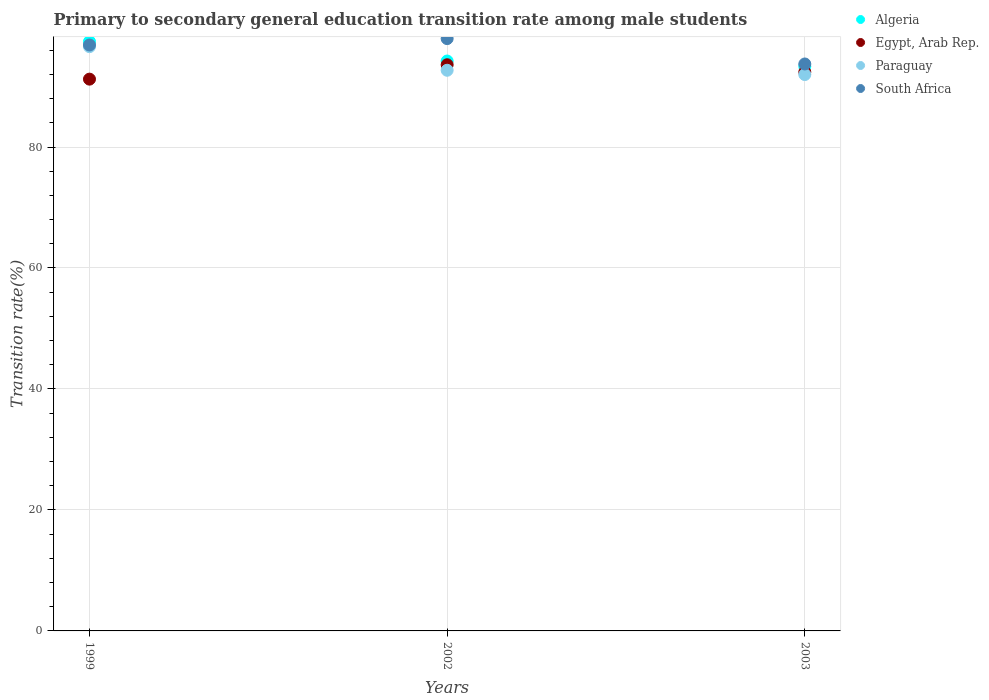What is the transition rate in Algeria in 2002?
Provide a succinct answer. 94.22. Across all years, what is the maximum transition rate in South Africa?
Provide a short and direct response. 97.92. Across all years, what is the minimum transition rate in Egypt, Arab Rep.?
Provide a short and direct response. 91.22. What is the total transition rate in Paraguay in the graph?
Keep it short and to the point. 281.25. What is the difference between the transition rate in South Africa in 1999 and that in 2002?
Keep it short and to the point. -1.06. What is the difference between the transition rate in South Africa in 2002 and the transition rate in Egypt, Arab Rep. in 2003?
Make the answer very short. 5.53. What is the average transition rate in Egypt, Arab Rep. per year?
Offer a terse response. 92.4. In the year 1999, what is the difference between the transition rate in Algeria and transition rate in Paraguay?
Give a very brief answer. 0.84. What is the ratio of the transition rate in Algeria in 1999 to that in 2003?
Your answer should be compact. 1.04. What is the difference between the highest and the second highest transition rate in Algeria?
Your answer should be very brief. 3.21. What is the difference between the highest and the lowest transition rate in Egypt, Arab Rep.?
Your answer should be very brief. 2.38. Is the sum of the transition rate in Algeria in 1999 and 2002 greater than the maximum transition rate in Egypt, Arab Rep. across all years?
Offer a terse response. Yes. Is it the case that in every year, the sum of the transition rate in South Africa and transition rate in Egypt, Arab Rep.  is greater than the transition rate in Algeria?
Your answer should be compact. Yes. Does the transition rate in Algeria monotonically increase over the years?
Ensure brevity in your answer.  No. Is the transition rate in South Africa strictly greater than the transition rate in Algeria over the years?
Provide a short and direct response. No. What is the difference between two consecutive major ticks on the Y-axis?
Offer a terse response. 20. Are the values on the major ticks of Y-axis written in scientific E-notation?
Your response must be concise. No. Does the graph contain any zero values?
Provide a succinct answer. No. How many legend labels are there?
Your response must be concise. 4. How are the legend labels stacked?
Offer a terse response. Vertical. What is the title of the graph?
Your response must be concise. Primary to secondary general education transition rate among male students. Does "Latin America(all income levels)" appear as one of the legend labels in the graph?
Make the answer very short. No. What is the label or title of the Y-axis?
Keep it short and to the point. Transition rate(%). What is the Transition rate(%) in Algeria in 1999?
Your answer should be compact. 97.42. What is the Transition rate(%) of Egypt, Arab Rep. in 1999?
Offer a terse response. 91.22. What is the Transition rate(%) of Paraguay in 1999?
Offer a terse response. 96.59. What is the Transition rate(%) of South Africa in 1999?
Ensure brevity in your answer.  96.86. What is the Transition rate(%) of Algeria in 2002?
Make the answer very short. 94.22. What is the Transition rate(%) in Egypt, Arab Rep. in 2002?
Offer a very short reply. 93.6. What is the Transition rate(%) of Paraguay in 2002?
Keep it short and to the point. 92.69. What is the Transition rate(%) of South Africa in 2002?
Offer a terse response. 97.92. What is the Transition rate(%) in Algeria in 2003?
Ensure brevity in your answer.  93.33. What is the Transition rate(%) in Egypt, Arab Rep. in 2003?
Provide a short and direct response. 92.39. What is the Transition rate(%) in Paraguay in 2003?
Offer a very short reply. 91.98. What is the Transition rate(%) of South Africa in 2003?
Your response must be concise. 93.73. Across all years, what is the maximum Transition rate(%) in Algeria?
Make the answer very short. 97.42. Across all years, what is the maximum Transition rate(%) in Egypt, Arab Rep.?
Offer a very short reply. 93.6. Across all years, what is the maximum Transition rate(%) in Paraguay?
Keep it short and to the point. 96.59. Across all years, what is the maximum Transition rate(%) in South Africa?
Make the answer very short. 97.92. Across all years, what is the minimum Transition rate(%) in Algeria?
Make the answer very short. 93.33. Across all years, what is the minimum Transition rate(%) of Egypt, Arab Rep.?
Your response must be concise. 91.22. Across all years, what is the minimum Transition rate(%) of Paraguay?
Give a very brief answer. 91.98. Across all years, what is the minimum Transition rate(%) in South Africa?
Ensure brevity in your answer.  93.73. What is the total Transition rate(%) in Algeria in the graph?
Keep it short and to the point. 284.97. What is the total Transition rate(%) of Egypt, Arab Rep. in the graph?
Make the answer very short. 277.21. What is the total Transition rate(%) in Paraguay in the graph?
Your answer should be compact. 281.25. What is the total Transition rate(%) of South Africa in the graph?
Ensure brevity in your answer.  288.51. What is the difference between the Transition rate(%) in Algeria in 1999 and that in 2002?
Give a very brief answer. 3.21. What is the difference between the Transition rate(%) in Egypt, Arab Rep. in 1999 and that in 2002?
Give a very brief answer. -2.38. What is the difference between the Transition rate(%) in Paraguay in 1999 and that in 2002?
Keep it short and to the point. 3.9. What is the difference between the Transition rate(%) of South Africa in 1999 and that in 2002?
Make the answer very short. -1.06. What is the difference between the Transition rate(%) of Algeria in 1999 and that in 2003?
Make the answer very short. 4.1. What is the difference between the Transition rate(%) of Egypt, Arab Rep. in 1999 and that in 2003?
Your answer should be compact. -1.17. What is the difference between the Transition rate(%) in Paraguay in 1999 and that in 2003?
Give a very brief answer. 4.61. What is the difference between the Transition rate(%) of South Africa in 1999 and that in 2003?
Keep it short and to the point. 3.14. What is the difference between the Transition rate(%) of Algeria in 2002 and that in 2003?
Ensure brevity in your answer.  0.89. What is the difference between the Transition rate(%) of Egypt, Arab Rep. in 2002 and that in 2003?
Offer a very short reply. 1.21. What is the difference between the Transition rate(%) of Paraguay in 2002 and that in 2003?
Keep it short and to the point. 0.71. What is the difference between the Transition rate(%) in South Africa in 2002 and that in 2003?
Make the answer very short. 4.19. What is the difference between the Transition rate(%) in Algeria in 1999 and the Transition rate(%) in Egypt, Arab Rep. in 2002?
Your answer should be compact. 3.83. What is the difference between the Transition rate(%) of Algeria in 1999 and the Transition rate(%) of Paraguay in 2002?
Keep it short and to the point. 4.74. What is the difference between the Transition rate(%) of Algeria in 1999 and the Transition rate(%) of South Africa in 2002?
Offer a very short reply. -0.5. What is the difference between the Transition rate(%) of Egypt, Arab Rep. in 1999 and the Transition rate(%) of Paraguay in 2002?
Provide a succinct answer. -1.47. What is the difference between the Transition rate(%) in Egypt, Arab Rep. in 1999 and the Transition rate(%) in South Africa in 2002?
Make the answer very short. -6.7. What is the difference between the Transition rate(%) in Paraguay in 1999 and the Transition rate(%) in South Africa in 2002?
Offer a terse response. -1.33. What is the difference between the Transition rate(%) in Algeria in 1999 and the Transition rate(%) in Egypt, Arab Rep. in 2003?
Provide a short and direct response. 5.03. What is the difference between the Transition rate(%) of Algeria in 1999 and the Transition rate(%) of Paraguay in 2003?
Make the answer very short. 5.45. What is the difference between the Transition rate(%) in Algeria in 1999 and the Transition rate(%) in South Africa in 2003?
Your answer should be very brief. 3.7. What is the difference between the Transition rate(%) in Egypt, Arab Rep. in 1999 and the Transition rate(%) in Paraguay in 2003?
Give a very brief answer. -0.76. What is the difference between the Transition rate(%) in Egypt, Arab Rep. in 1999 and the Transition rate(%) in South Africa in 2003?
Your answer should be compact. -2.51. What is the difference between the Transition rate(%) in Paraguay in 1999 and the Transition rate(%) in South Africa in 2003?
Ensure brevity in your answer.  2.86. What is the difference between the Transition rate(%) of Algeria in 2002 and the Transition rate(%) of Egypt, Arab Rep. in 2003?
Give a very brief answer. 1.82. What is the difference between the Transition rate(%) in Algeria in 2002 and the Transition rate(%) in Paraguay in 2003?
Your response must be concise. 2.24. What is the difference between the Transition rate(%) in Algeria in 2002 and the Transition rate(%) in South Africa in 2003?
Ensure brevity in your answer.  0.49. What is the difference between the Transition rate(%) in Egypt, Arab Rep. in 2002 and the Transition rate(%) in Paraguay in 2003?
Make the answer very short. 1.62. What is the difference between the Transition rate(%) of Egypt, Arab Rep. in 2002 and the Transition rate(%) of South Africa in 2003?
Your answer should be very brief. -0.13. What is the difference between the Transition rate(%) of Paraguay in 2002 and the Transition rate(%) of South Africa in 2003?
Offer a very short reply. -1.04. What is the average Transition rate(%) in Algeria per year?
Provide a short and direct response. 94.99. What is the average Transition rate(%) of Egypt, Arab Rep. per year?
Give a very brief answer. 92.4. What is the average Transition rate(%) of Paraguay per year?
Offer a very short reply. 93.75. What is the average Transition rate(%) in South Africa per year?
Ensure brevity in your answer.  96.17. In the year 1999, what is the difference between the Transition rate(%) in Algeria and Transition rate(%) in Egypt, Arab Rep.?
Provide a succinct answer. 6.2. In the year 1999, what is the difference between the Transition rate(%) in Algeria and Transition rate(%) in Paraguay?
Provide a succinct answer. 0.84. In the year 1999, what is the difference between the Transition rate(%) of Algeria and Transition rate(%) of South Africa?
Make the answer very short. 0.56. In the year 1999, what is the difference between the Transition rate(%) of Egypt, Arab Rep. and Transition rate(%) of Paraguay?
Provide a succinct answer. -5.37. In the year 1999, what is the difference between the Transition rate(%) of Egypt, Arab Rep. and Transition rate(%) of South Africa?
Your answer should be very brief. -5.64. In the year 1999, what is the difference between the Transition rate(%) of Paraguay and Transition rate(%) of South Africa?
Your answer should be compact. -0.28. In the year 2002, what is the difference between the Transition rate(%) of Algeria and Transition rate(%) of Egypt, Arab Rep.?
Your answer should be very brief. 0.62. In the year 2002, what is the difference between the Transition rate(%) in Algeria and Transition rate(%) in Paraguay?
Provide a short and direct response. 1.53. In the year 2002, what is the difference between the Transition rate(%) in Algeria and Transition rate(%) in South Africa?
Make the answer very short. -3.71. In the year 2002, what is the difference between the Transition rate(%) of Egypt, Arab Rep. and Transition rate(%) of Paraguay?
Offer a very short reply. 0.91. In the year 2002, what is the difference between the Transition rate(%) in Egypt, Arab Rep. and Transition rate(%) in South Africa?
Ensure brevity in your answer.  -4.32. In the year 2002, what is the difference between the Transition rate(%) in Paraguay and Transition rate(%) in South Africa?
Make the answer very short. -5.23. In the year 2003, what is the difference between the Transition rate(%) of Algeria and Transition rate(%) of Egypt, Arab Rep.?
Provide a succinct answer. 0.93. In the year 2003, what is the difference between the Transition rate(%) in Algeria and Transition rate(%) in Paraguay?
Offer a terse response. 1.35. In the year 2003, what is the difference between the Transition rate(%) of Algeria and Transition rate(%) of South Africa?
Give a very brief answer. -0.4. In the year 2003, what is the difference between the Transition rate(%) in Egypt, Arab Rep. and Transition rate(%) in Paraguay?
Make the answer very short. 0.41. In the year 2003, what is the difference between the Transition rate(%) of Egypt, Arab Rep. and Transition rate(%) of South Africa?
Make the answer very short. -1.33. In the year 2003, what is the difference between the Transition rate(%) of Paraguay and Transition rate(%) of South Africa?
Ensure brevity in your answer.  -1.75. What is the ratio of the Transition rate(%) in Algeria in 1999 to that in 2002?
Provide a succinct answer. 1.03. What is the ratio of the Transition rate(%) in Egypt, Arab Rep. in 1999 to that in 2002?
Keep it short and to the point. 0.97. What is the ratio of the Transition rate(%) in Paraguay in 1999 to that in 2002?
Your answer should be compact. 1.04. What is the ratio of the Transition rate(%) in South Africa in 1999 to that in 2002?
Make the answer very short. 0.99. What is the ratio of the Transition rate(%) of Algeria in 1999 to that in 2003?
Provide a succinct answer. 1.04. What is the ratio of the Transition rate(%) of Egypt, Arab Rep. in 1999 to that in 2003?
Offer a very short reply. 0.99. What is the ratio of the Transition rate(%) of Paraguay in 1999 to that in 2003?
Your response must be concise. 1.05. What is the ratio of the Transition rate(%) of South Africa in 1999 to that in 2003?
Keep it short and to the point. 1.03. What is the ratio of the Transition rate(%) of Algeria in 2002 to that in 2003?
Provide a succinct answer. 1.01. What is the ratio of the Transition rate(%) in Paraguay in 2002 to that in 2003?
Ensure brevity in your answer.  1.01. What is the ratio of the Transition rate(%) in South Africa in 2002 to that in 2003?
Offer a terse response. 1.04. What is the difference between the highest and the second highest Transition rate(%) of Algeria?
Give a very brief answer. 3.21. What is the difference between the highest and the second highest Transition rate(%) in Egypt, Arab Rep.?
Your response must be concise. 1.21. What is the difference between the highest and the second highest Transition rate(%) of Paraguay?
Provide a succinct answer. 3.9. What is the difference between the highest and the second highest Transition rate(%) in South Africa?
Offer a terse response. 1.06. What is the difference between the highest and the lowest Transition rate(%) of Algeria?
Your answer should be very brief. 4.1. What is the difference between the highest and the lowest Transition rate(%) in Egypt, Arab Rep.?
Offer a terse response. 2.38. What is the difference between the highest and the lowest Transition rate(%) in Paraguay?
Your response must be concise. 4.61. What is the difference between the highest and the lowest Transition rate(%) of South Africa?
Offer a terse response. 4.19. 